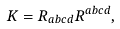Convert formula to latex. <formula><loc_0><loc_0><loc_500><loc_500>K = R _ { a b c d } R ^ { a b c d } ,</formula> 